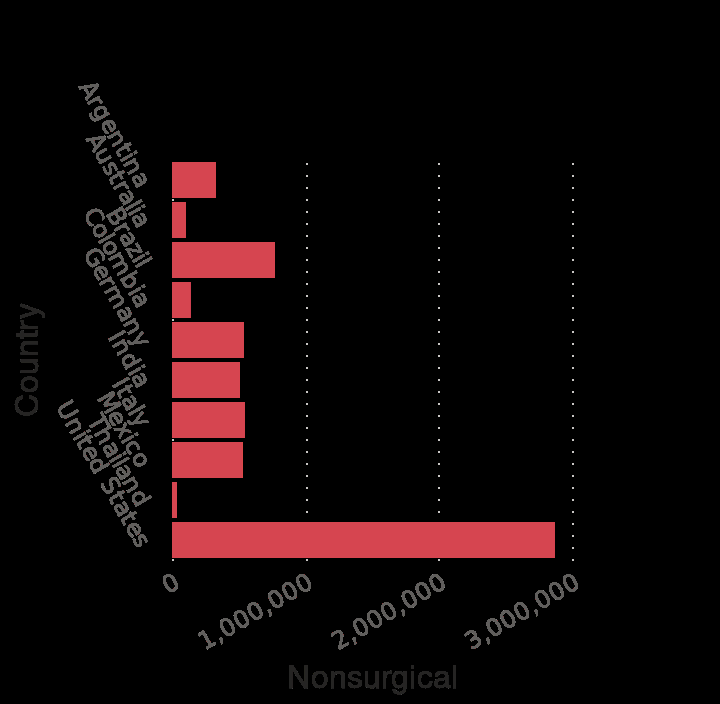<image>
What does the figure suggest about the relationship between population and response?  The figure suggests that there is a larger response based on population. What does the bar plot reveal about the countries? The bar plot reveals the countries with the highest number of cosmetic procedures, both surgical and nonsurgical, in 2018. 